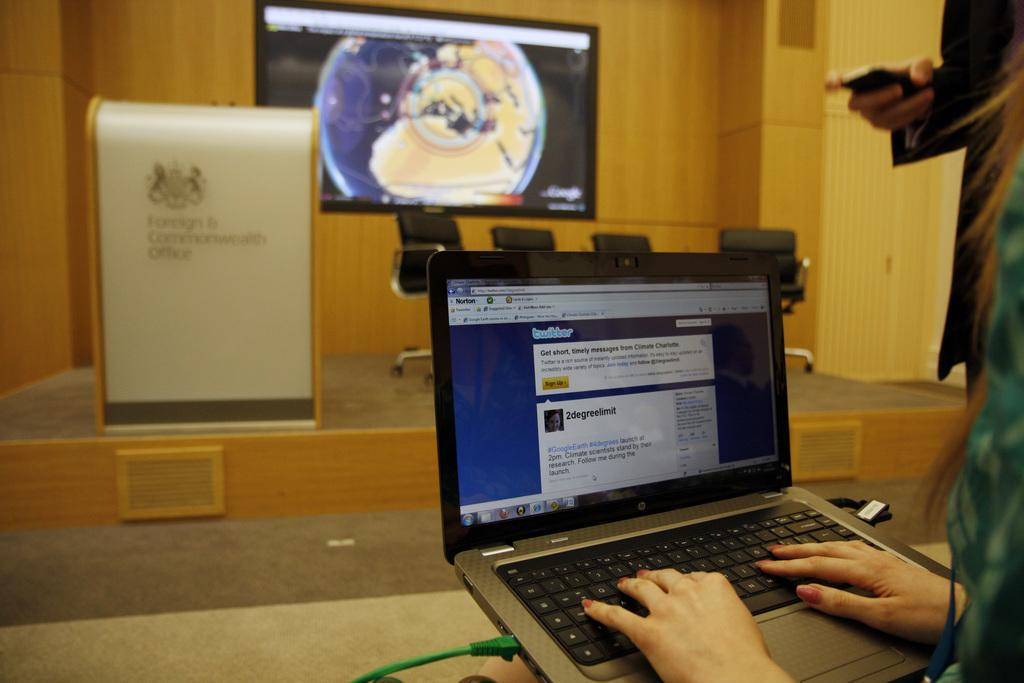Provide a one-sentence caption for the provided image. Norton is protecting her computer as she types a message on twitter. 